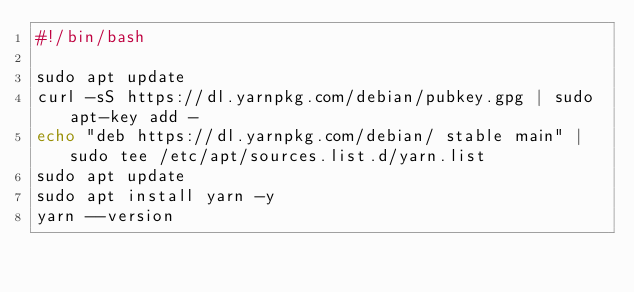Convert code to text. <code><loc_0><loc_0><loc_500><loc_500><_Bash_>#!/bin/bash

sudo apt update
curl -sS https://dl.yarnpkg.com/debian/pubkey.gpg | sudo apt-key add -
echo "deb https://dl.yarnpkg.com/debian/ stable main" | sudo tee /etc/apt/sources.list.d/yarn.list
sudo apt update
sudo apt install yarn -y
yarn --version</code> 